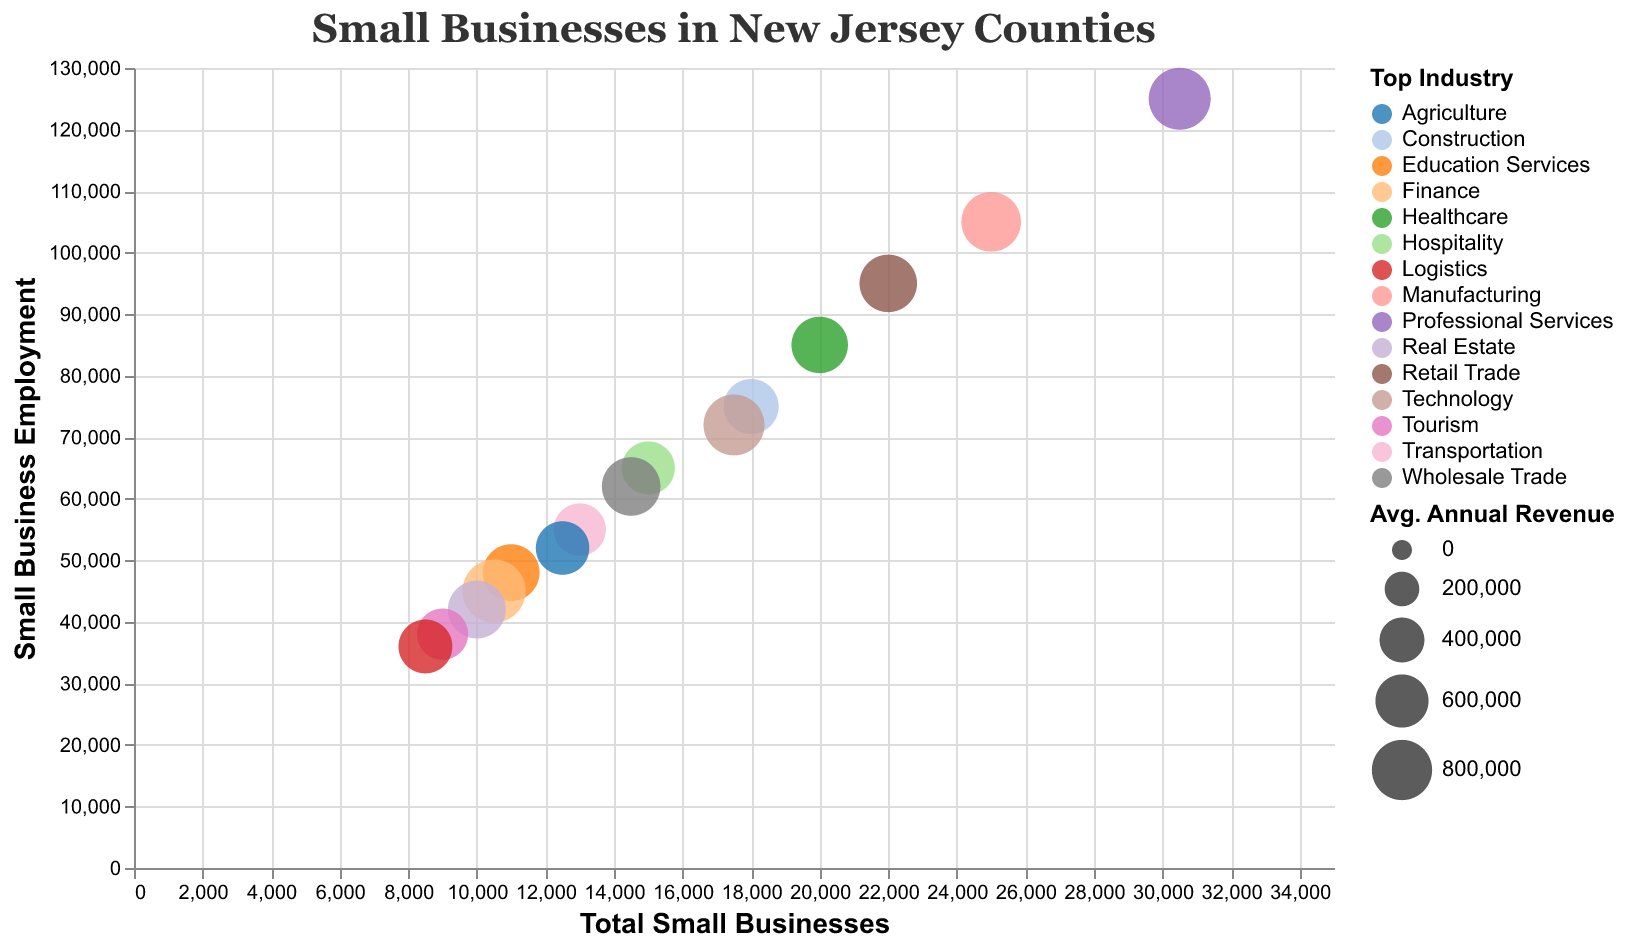What is the county with the highest number of total small businesses? By looking at the x-axis labeled "Total Small Businesses," we can identify the county with the highest value. The county is Bergen with 30,500 small businesses.
Answer: Bergen Which county has the top industry in Healthcare? Check the legend for the "Top Industry" and locate the circle that corresponds to Healthcare. The county is Monmouth.
Answer: Monmouth How much is the average annual revenue of small businesses in Somerset County? Find the tooltip or data point for Somerset County and refer to the "Avg. Annual Revenue" field. The average annual revenue is $890,000.
Answer: $890,000 Which county has the smallest number of total small businesses and what is its top industry? Locate the data point with the smallest value on the x-axis, which is Gloucester with 8,500 small businesses. The top industry in Gloucester is Logistics.
Answer: Gloucester, Logistics What is the total small business employment in Essex County? Identify the data point for Essex County and look at the y-axis value labeled "Small Business Employment," which is 95,000.
Answer: 95,000 What is the combined small business employment in Bergen and Middlesex counties? Add the small business employment of Bergen (125,000) and Middlesex (105,000). 125,000 + 105,000 = 230,000.
Answer: 230,000 Which county has a higher average annual revenue for small businesses, Morris or Hudson? Compare the "Avg. Annual Revenue" for Morris ($820,000) and Hudson ($730,000). Morris has a higher average annual revenue.
Answer: Morris What is the difference in total small businesses between Ocean and Camden counties? Subtract the number of small businesses in Camden (15,000) from Ocean (18,000). 18,000 - 15,000 = 3,000.
Answer: 3,000 Which county's top industry is Agriculture and what is its average annual revenue? Locate the data point corresponding to Agriculture using the legend. Burlington County has Agriculture as the top industry and its average annual revenue is $610,000.
Answer: Burlington, $610,000 What is the average small business employment among the counties with "Real Estate" and "Finance" as their top industry? Identify the data points for Hudson (Real Estate, 42,000) and Somerset (Finance, 45,000). Add them and divide by 2 for the average. (42,000 + 45,000) / 2 = 43,500.
Answer: 43,500 